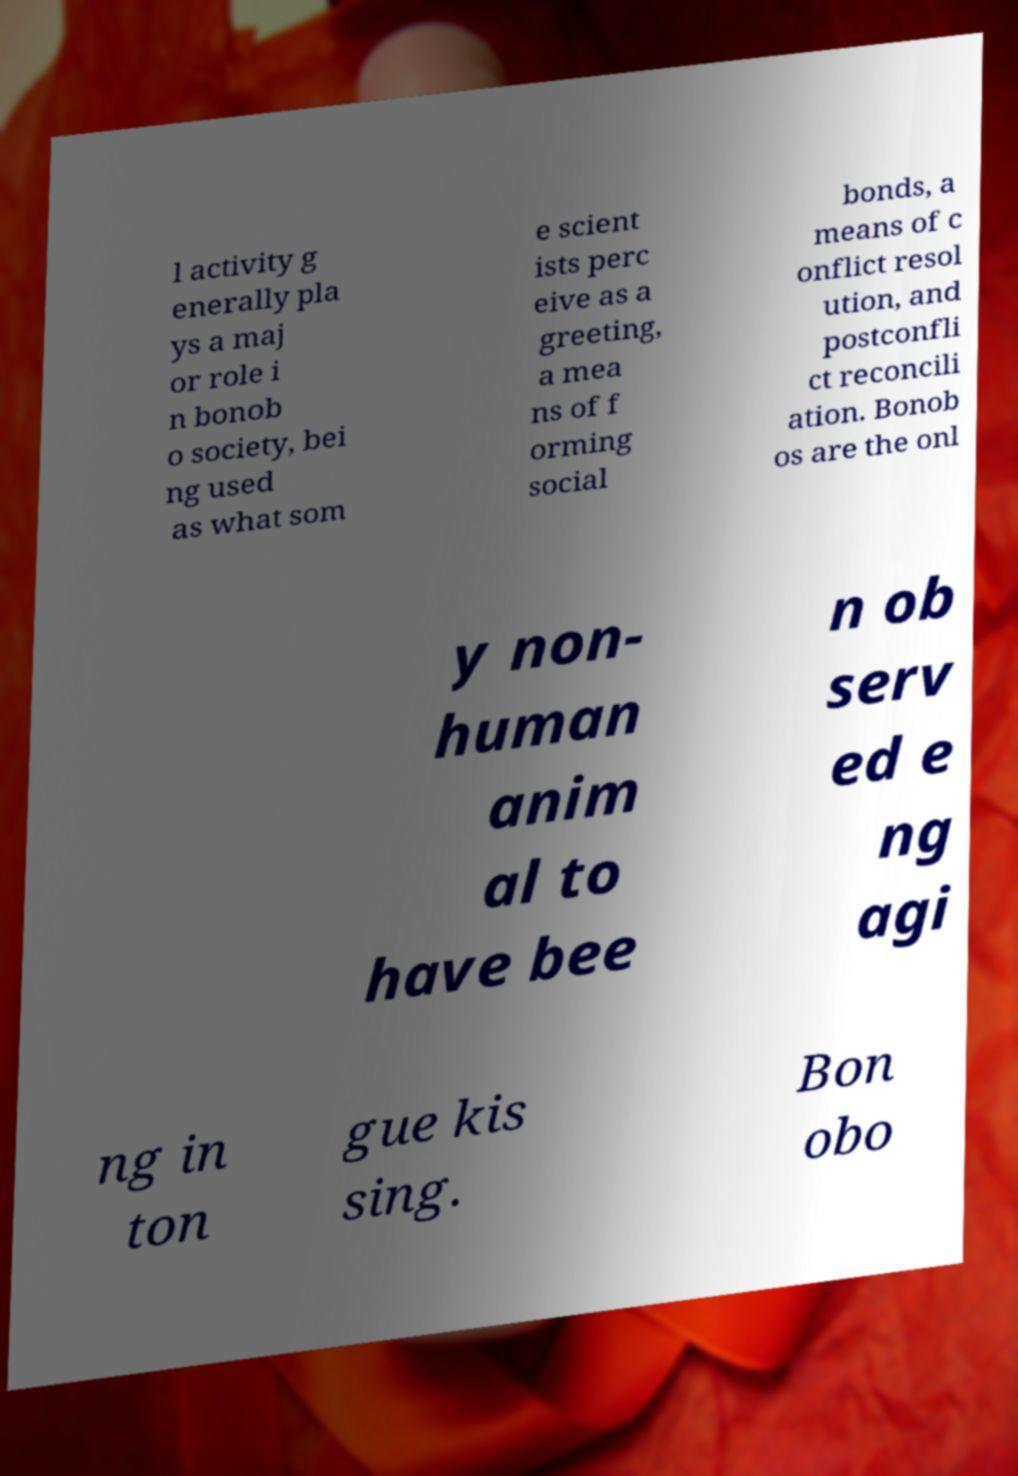Could you assist in decoding the text presented in this image and type it out clearly? l activity g enerally pla ys a maj or role i n bonob o society, bei ng used as what som e scient ists perc eive as a greeting, a mea ns of f orming social bonds, a means of c onflict resol ution, and postconfli ct reconcili ation. Bonob os are the onl y non- human anim al to have bee n ob serv ed e ng agi ng in ton gue kis sing. Bon obo 